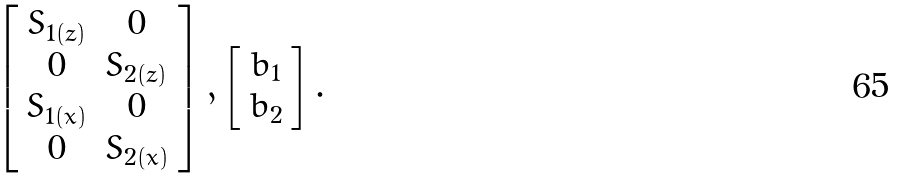<formula> <loc_0><loc_0><loc_500><loc_500>\left [ \begin{array} { c c } S _ { 1 ( z ) } & 0 \\ 0 & S _ { 2 ( z ) } \\ S _ { 1 ( x ) } & 0 \\ 0 & S _ { 2 ( x ) } \end{array} \right ] , \left [ \begin{array} { c c } b _ { 1 } \\ b _ { 2 } \end{array} \right ] .</formula> 